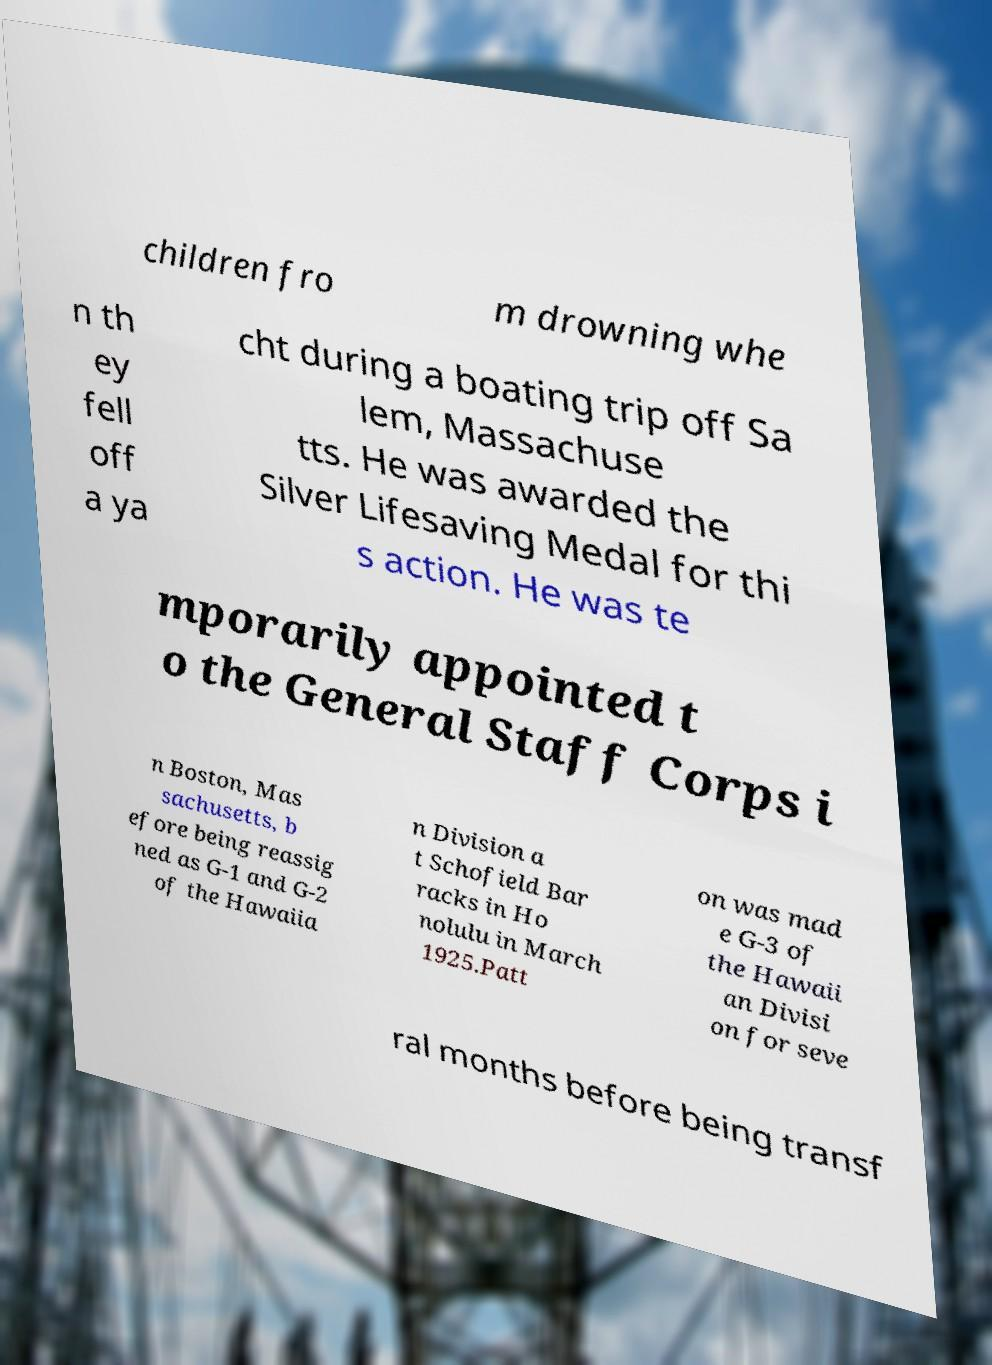Please read and relay the text visible in this image. What does it say? children fro m drowning whe n th ey fell off a ya cht during a boating trip off Sa lem, Massachuse tts. He was awarded the Silver Lifesaving Medal for thi s action. He was te mporarily appointed t o the General Staff Corps i n Boston, Mas sachusetts, b efore being reassig ned as G-1 and G-2 of the Hawaiia n Division a t Schofield Bar racks in Ho nolulu in March 1925.Patt on was mad e G-3 of the Hawaii an Divisi on for seve ral months before being transf 